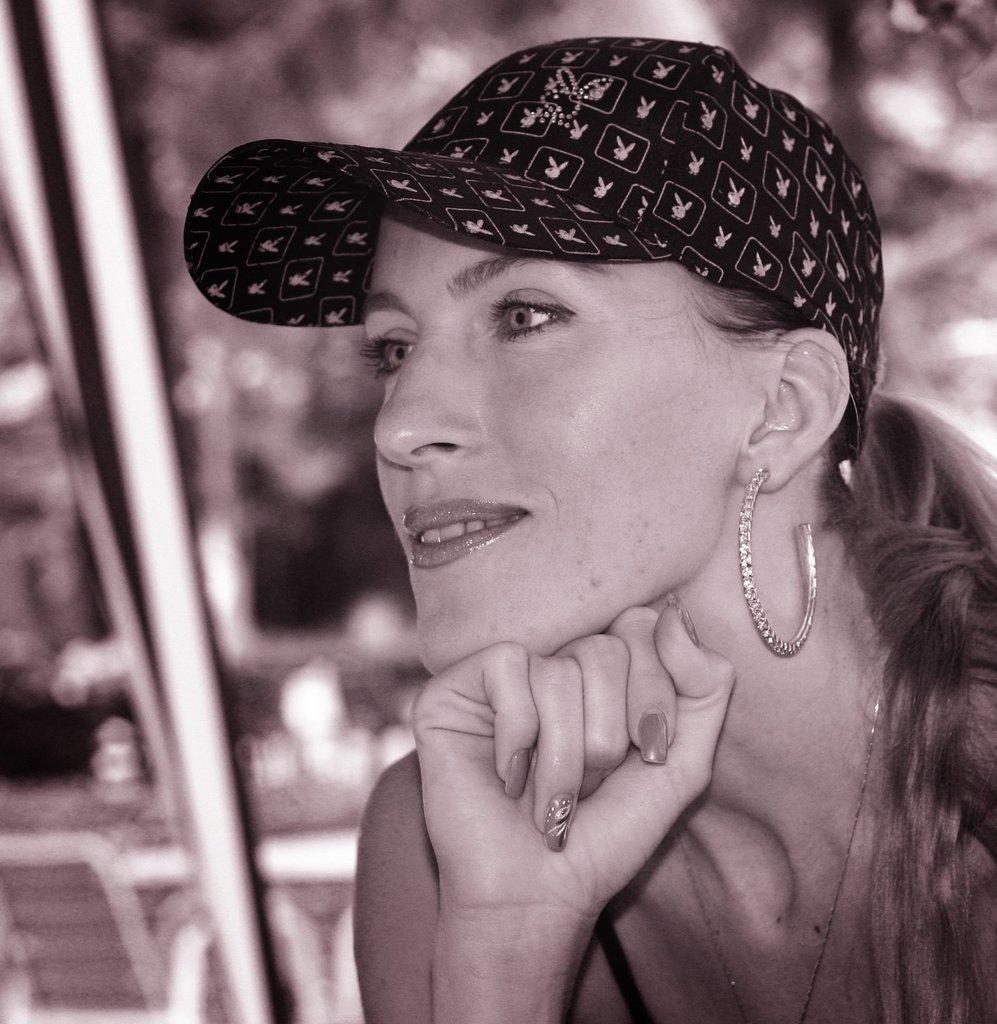Describe this image in one or two sentences. In this image I can see the person wearing the earring and the cap. And there is a blurred background. 